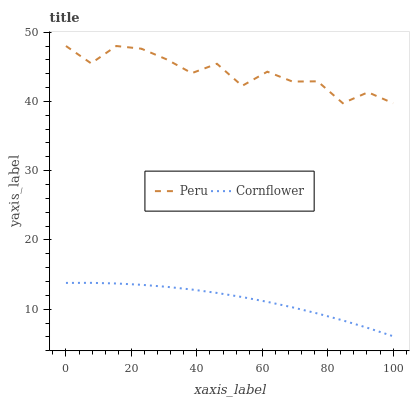Does Cornflower have the minimum area under the curve?
Answer yes or no. Yes. Does Peru have the maximum area under the curve?
Answer yes or no. Yes. Does Peru have the minimum area under the curve?
Answer yes or no. No. Is Cornflower the smoothest?
Answer yes or no. Yes. Is Peru the roughest?
Answer yes or no. Yes. Is Peru the smoothest?
Answer yes or no. No. Does Peru have the lowest value?
Answer yes or no. No. Does Peru have the highest value?
Answer yes or no. Yes. Is Cornflower less than Peru?
Answer yes or no. Yes. Is Peru greater than Cornflower?
Answer yes or no. Yes. Does Cornflower intersect Peru?
Answer yes or no. No. 